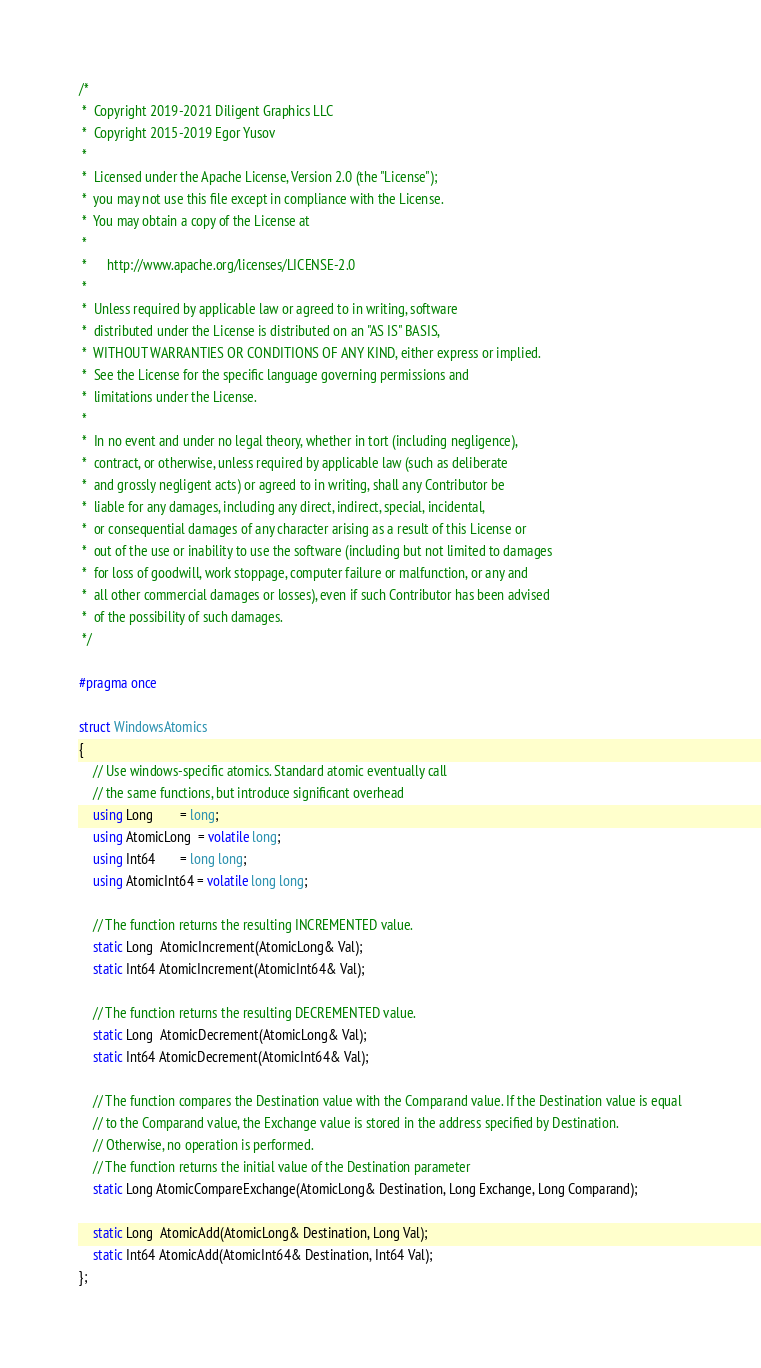<code> <loc_0><loc_0><loc_500><loc_500><_C++_>/*
 *  Copyright 2019-2021 Diligent Graphics LLC
 *  Copyright 2015-2019 Egor Yusov
 *
 *  Licensed under the Apache License, Version 2.0 (the "License");
 *  you may not use this file except in compliance with the License.
 *  You may obtain a copy of the License at
 *
 *      http://www.apache.org/licenses/LICENSE-2.0
 *
 *  Unless required by applicable law or agreed to in writing, software
 *  distributed under the License is distributed on an "AS IS" BASIS,
 *  WITHOUT WARRANTIES OR CONDITIONS OF ANY KIND, either express or implied.
 *  See the License for the specific language governing permissions and
 *  limitations under the License.
 *
 *  In no event and under no legal theory, whether in tort (including negligence),
 *  contract, or otherwise, unless required by applicable law (such as deliberate
 *  and grossly negligent acts) or agreed to in writing, shall any Contributor be
 *  liable for any damages, including any direct, indirect, special, incidental,
 *  or consequential damages of any character arising as a result of this License or
 *  out of the use or inability to use the software (including but not limited to damages
 *  for loss of goodwill, work stoppage, computer failure or malfunction, or any and
 *  all other commercial damages or losses), even if such Contributor has been advised
 *  of the possibility of such damages.
 */

#pragma once

struct WindowsAtomics
{
    // Use windows-specific atomics. Standard atomic eventually call
    // the same functions, but introduce significant overhead
    using Long        = long;
    using AtomicLong  = volatile long;
    using Int64       = long long;
    using AtomicInt64 = volatile long long;

    // The function returns the resulting INCREMENTED value.
    static Long  AtomicIncrement(AtomicLong& Val);
    static Int64 AtomicIncrement(AtomicInt64& Val);

    // The function returns the resulting DECREMENTED value.
    static Long  AtomicDecrement(AtomicLong& Val);
    static Int64 AtomicDecrement(AtomicInt64& Val);

    // The function compares the Destination value with the Comparand value. If the Destination value is equal
    // to the Comparand value, the Exchange value is stored in the address specified by Destination.
    // Otherwise, no operation is performed.
    // The function returns the initial value of the Destination parameter
    static Long AtomicCompareExchange(AtomicLong& Destination, Long Exchange, Long Comparand);

    static Long  AtomicAdd(AtomicLong& Destination, Long Val);
    static Int64 AtomicAdd(AtomicInt64& Destination, Int64 Val);
};
</code> 